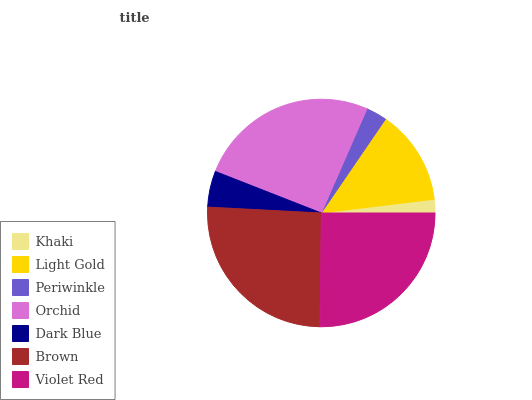Is Khaki the minimum?
Answer yes or no. Yes. Is Brown the maximum?
Answer yes or no. Yes. Is Light Gold the minimum?
Answer yes or no. No. Is Light Gold the maximum?
Answer yes or no. No. Is Light Gold greater than Khaki?
Answer yes or no. Yes. Is Khaki less than Light Gold?
Answer yes or no. Yes. Is Khaki greater than Light Gold?
Answer yes or no. No. Is Light Gold less than Khaki?
Answer yes or no. No. Is Light Gold the high median?
Answer yes or no. Yes. Is Light Gold the low median?
Answer yes or no. Yes. Is Periwinkle the high median?
Answer yes or no. No. Is Brown the low median?
Answer yes or no. No. 